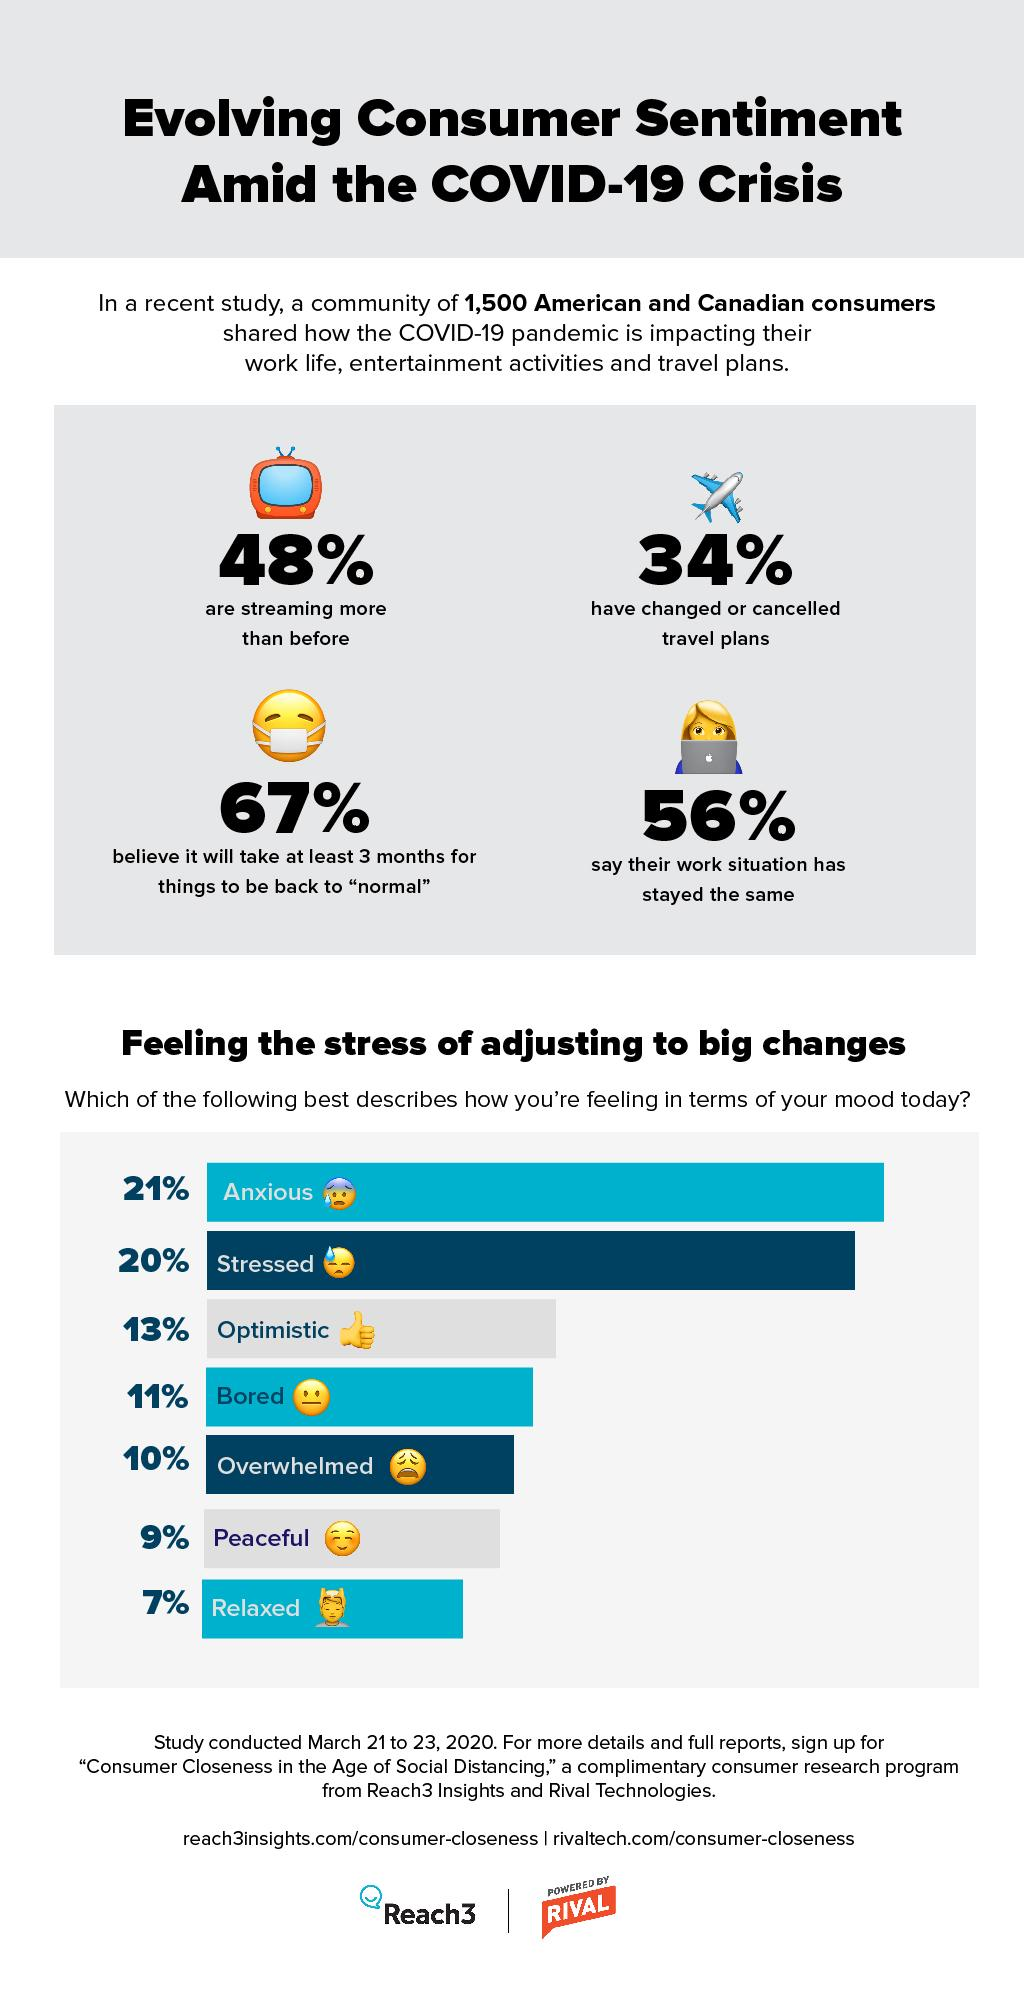Outline some significant characteristics in this image. Thirty-four percent of people have altered their trip plans. According to the data, 16% of the participants reported feeling peaceful and relaxed. A majority of individuals, 56%, have experienced no change in their work situation. According to a survey, 67% of people believe that their lives will return to normal within the next 3 months. 